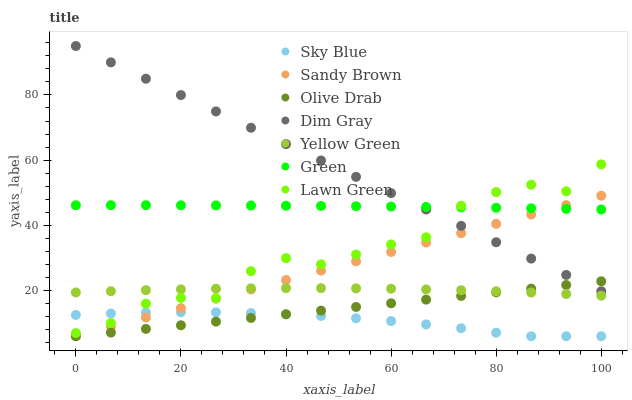Does Sky Blue have the minimum area under the curve?
Answer yes or no. Yes. Does Dim Gray have the maximum area under the curve?
Answer yes or no. Yes. Does Yellow Green have the minimum area under the curve?
Answer yes or no. No. Does Yellow Green have the maximum area under the curve?
Answer yes or no. No. Is Olive Drab the smoothest?
Answer yes or no. Yes. Is Lawn Green the roughest?
Answer yes or no. Yes. Is Dim Gray the smoothest?
Answer yes or no. No. Is Dim Gray the roughest?
Answer yes or no. No. Does Sky Blue have the lowest value?
Answer yes or no. Yes. Does Dim Gray have the lowest value?
Answer yes or no. No. Does Dim Gray have the highest value?
Answer yes or no. Yes. Does Yellow Green have the highest value?
Answer yes or no. No. Is Sky Blue less than Green?
Answer yes or no. Yes. Is Lawn Green greater than Olive Drab?
Answer yes or no. Yes. Does Sandy Brown intersect Olive Drab?
Answer yes or no. Yes. Is Sandy Brown less than Olive Drab?
Answer yes or no. No. Is Sandy Brown greater than Olive Drab?
Answer yes or no. No. Does Sky Blue intersect Green?
Answer yes or no. No. 